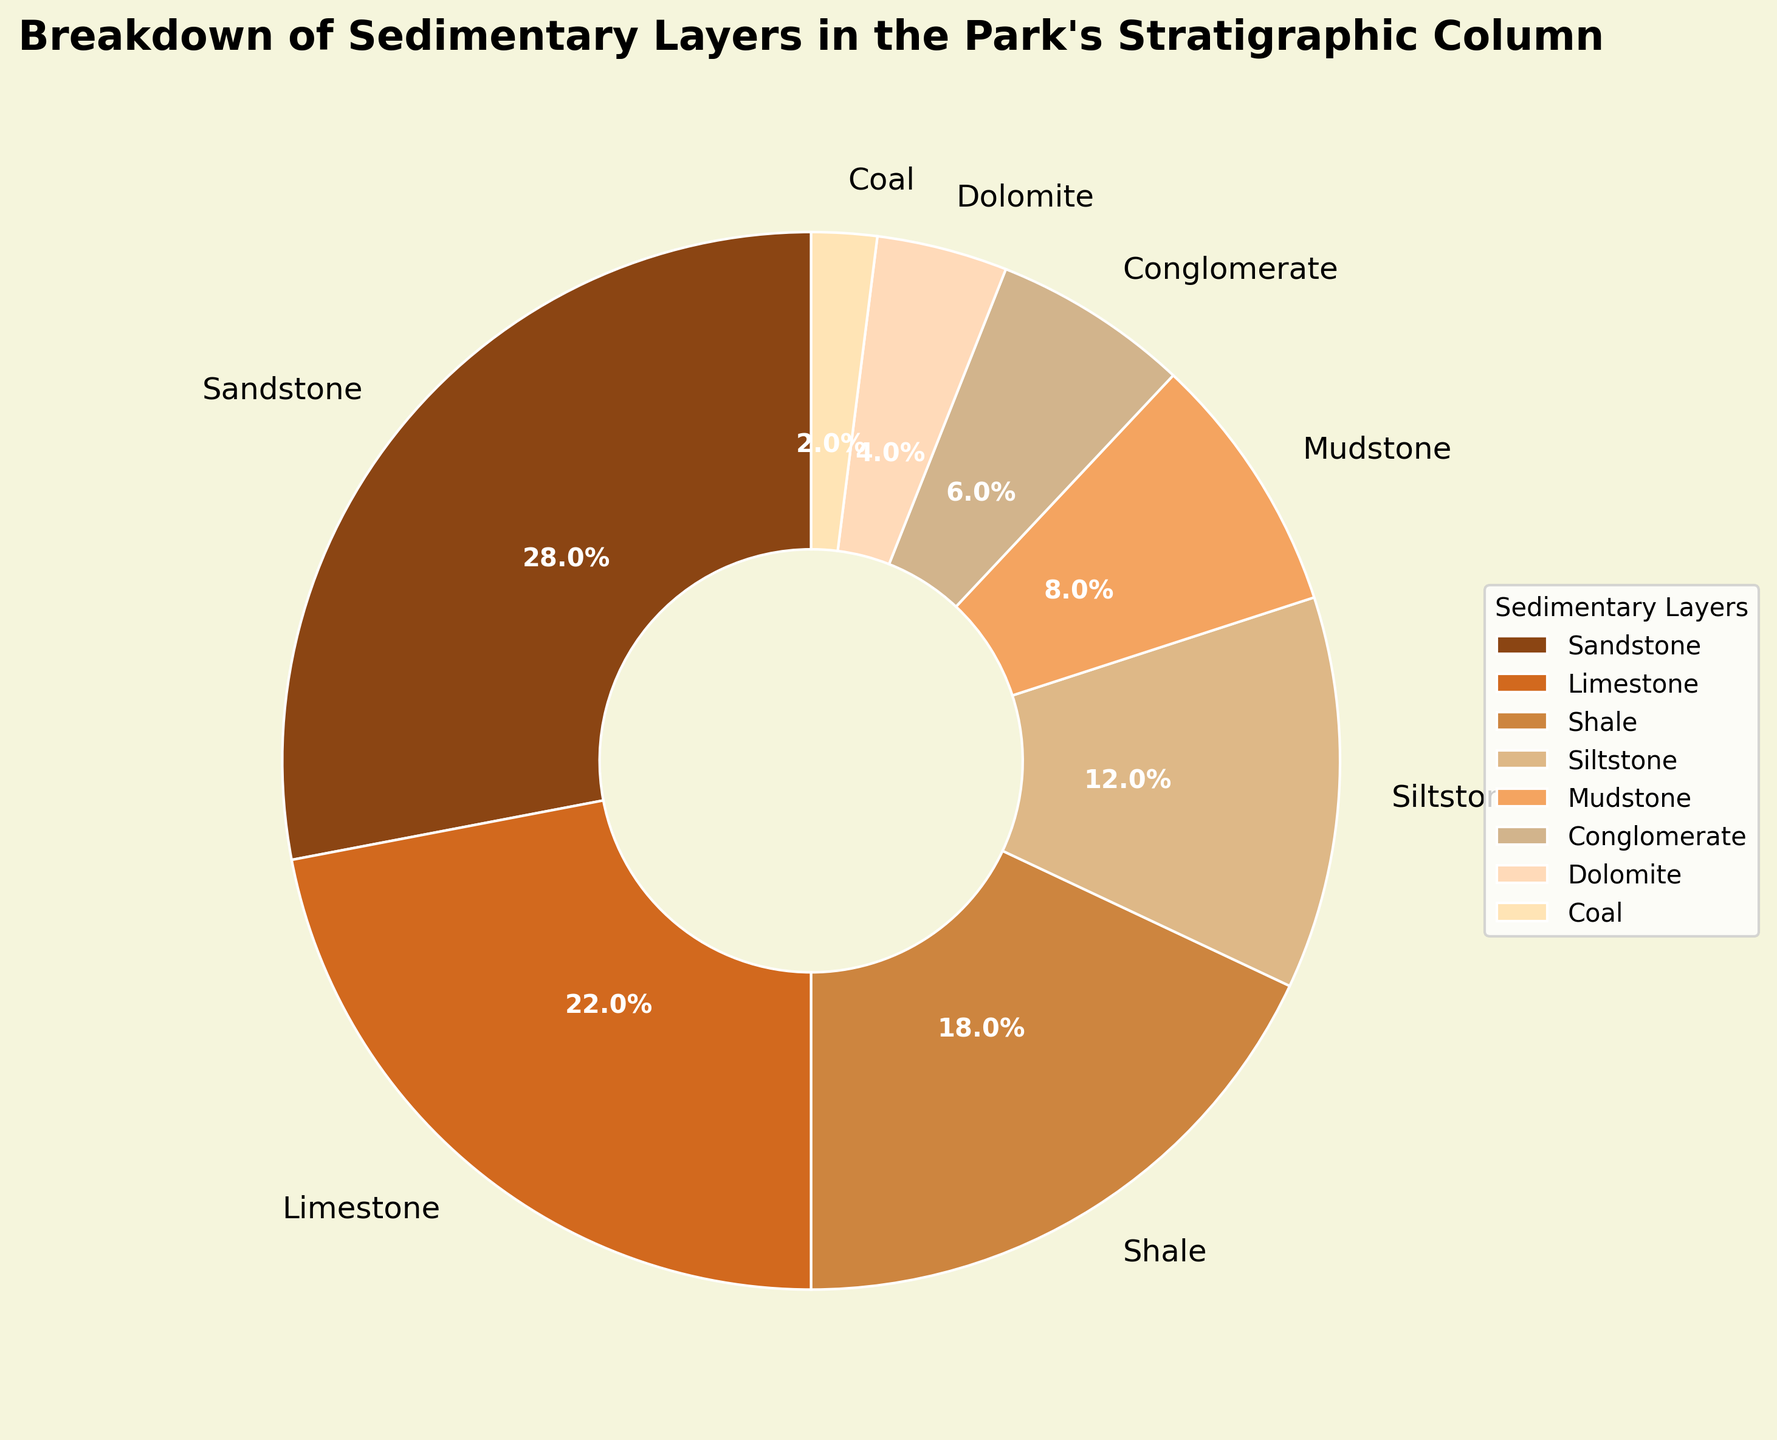How much percentage do sandstone and limestone layers together constitute? First, identify the percentage of sandstone, which is 28%. Then, identify the percentage of limestone, which is 22%. Sum these two numbers: 28% + 22% = 50%
Answer: 50% Which sedimentary layer has the smallest representation in the stratigraphic column? Look at the percentages for each sedimentary layer and find the smallest one. Coal has 2%, which is the smallest among the given layers.
Answer: Coal Is the percentage of the mudstone layer greater than that of the dolomite layer? First, identify the percentage of mudstone, which is 8%. Then, identify the percentage of dolomite, which is 4%. Compare the two: 8% is greater than 4%.
Answer: Yes What is the difference in percentage between conglomerate and siltstone layers? First, identify the percentage of conglomerate, which is 6%. Then, identify the percentage of the siltstone, which is 12%. Calculate the difference: 12% - 6% = 6%.
Answer: 6% Among the sedimentary layers, which one has the second highest percentage? Identify the percentages of all layers and then find the second highest number. Sandstone has the highest percentage at 28%, and limestone has the second highest percentage at 22%.
Answer: Limestone List the sedimentary layers in descending order of their percentages. Review the provided data for all percentages: Sandstone (28%), Limestone (22%), Shale (18%), Siltstone (12%), Mudstone (8%), Conglomerate (6%), Dolomite (4%), Coal (2%). Sort these values in descending order to get the sequence.
Answer: Sandstone, Limestone, Shale, Siltstone, Mudstone, Conglomerate, Dolomite, Coal Are the percentages of shale and siltstone layers together more than that of the limestone layer? Identify the percentage of shale which is 18%. Identify the percentage of siltstone which is 12%. First, sum these two values: 18% + 12% = 30%. Then compare this sum to the percentage of the limestone, which is 22%. 30% is greater than 22%.
Answer: Yes What percentage of the stratigraphic column is made up of mudstone and conglomerate? Identify the percentage of mudstone which is 8%. Identify the percentage of the conglomerate which is 6%. Sum these two values: 8% + 6% = 14%.
Answer: 14% 